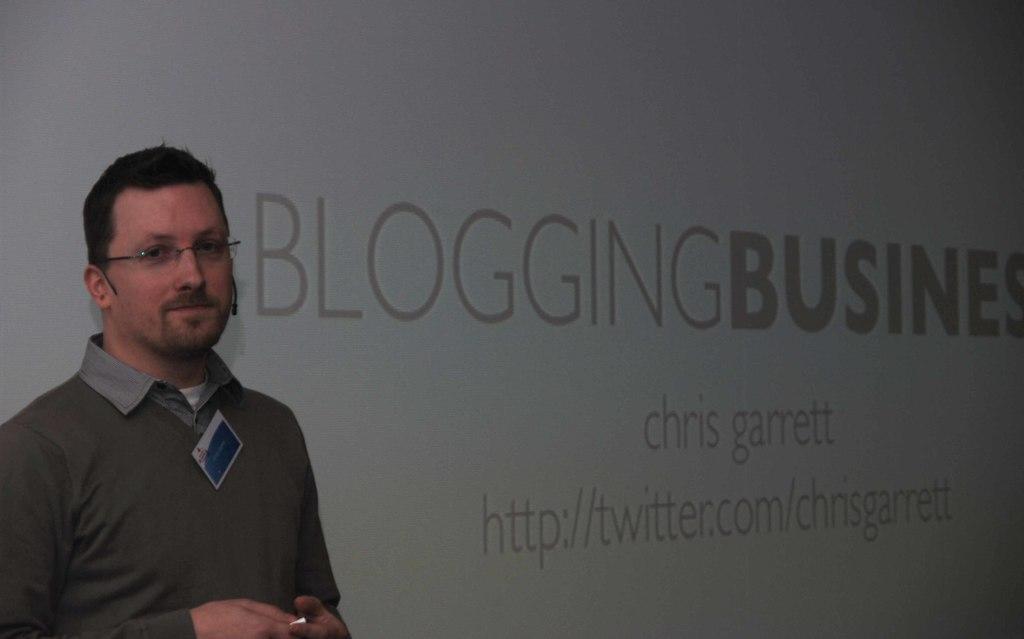Describe this image in one or two sentences. In this image, I can see the man standing and smiling. He wore a shirt and a spectacle. This looks like a badge. I think this is a kind of a hoarding with the letters on it. 